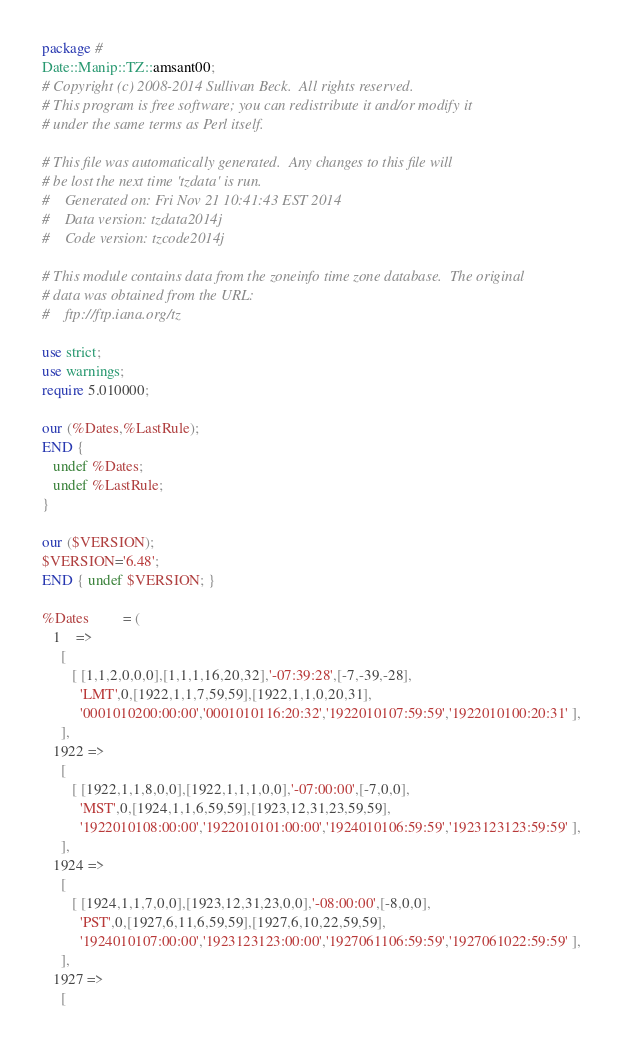<code> <loc_0><loc_0><loc_500><loc_500><_Perl_>package #
Date::Manip::TZ::amsant00;
# Copyright (c) 2008-2014 Sullivan Beck.  All rights reserved.
# This program is free software; you can redistribute it and/or modify it
# under the same terms as Perl itself.

# This file was automatically generated.  Any changes to this file will
# be lost the next time 'tzdata' is run.
#    Generated on: Fri Nov 21 10:41:43 EST 2014
#    Data version: tzdata2014j
#    Code version: tzcode2014j

# This module contains data from the zoneinfo time zone database.  The original
# data was obtained from the URL:
#    ftp://ftp.iana.org/tz

use strict;
use warnings;
require 5.010000;

our (%Dates,%LastRule);
END {
   undef %Dates;
   undef %LastRule;
}

our ($VERSION);
$VERSION='6.48';
END { undef $VERSION; }

%Dates         = (
   1    =>
     [
        [ [1,1,2,0,0,0],[1,1,1,16,20,32],'-07:39:28',[-7,-39,-28],
          'LMT',0,[1922,1,1,7,59,59],[1922,1,1,0,20,31],
          '0001010200:00:00','0001010116:20:32','1922010107:59:59','1922010100:20:31' ],
     ],
   1922 =>
     [
        [ [1922,1,1,8,0,0],[1922,1,1,1,0,0],'-07:00:00',[-7,0,0],
          'MST',0,[1924,1,1,6,59,59],[1923,12,31,23,59,59],
          '1922010108:00:00','1922010101:00:00','1924010106:59:59','1923123123:59:59' ],
     ],
   1924 =>
     [
        [ [1924,1,1,7,0,0],[1923,12,31,23,0,0],'-08:00:00',[-8,0,0],
          'PST',0,[1927,6,11,6,59,59],[1927,6,10,22,59,59],
          '1924010107:00:00','1923123123:00:00','1927061106:59:59','1927061022:59:59' ],
     ],
   1927 =>
     [</code> 